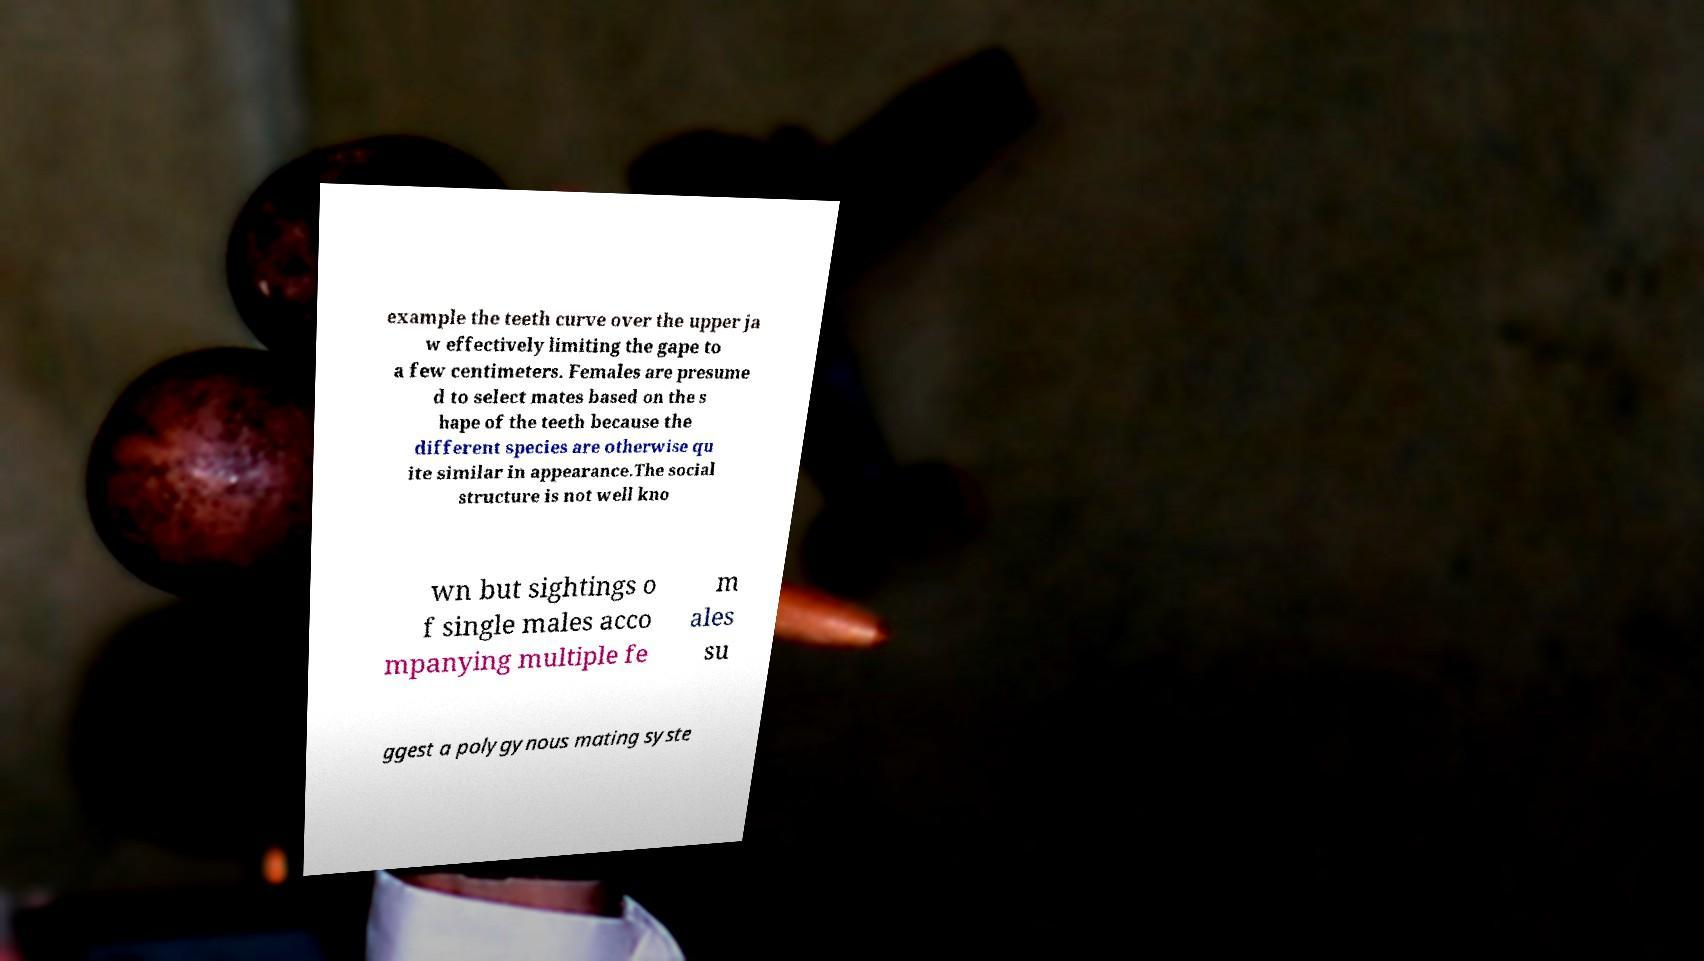Can you read and provide the text displayed in the image?This photo seems to have some interesting text. Can you extract and type it out for me? example the teeth curve over the upper ja w effectively limiting the gape to a few centimeters. Females are presume d to select mates based on the s hape of the teeth because the different species are otherwise qu ite similar in appearance.The social structure is not well kno wn but sightings o f single males acco mpanying multiple fe m ales su ggest a polygynous mating syste 